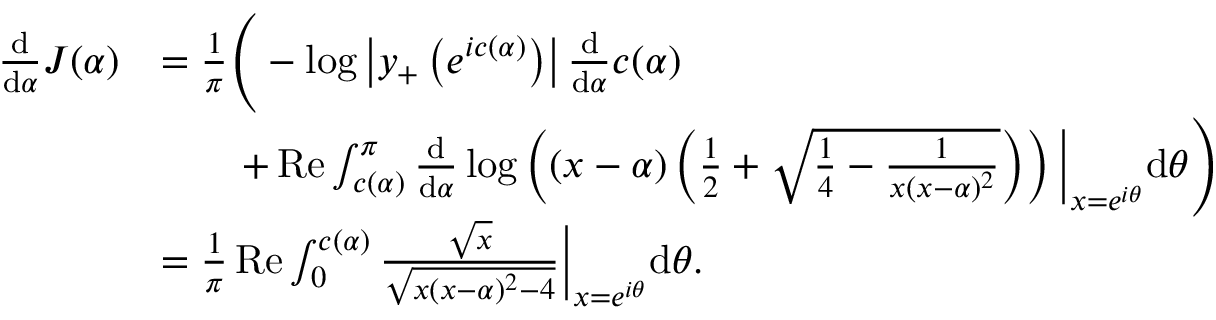Convert formula to latex. <formula><loc_0><loc_0><loc_500><loc_500>\begin{array} { r l } { \frac { \mathrm d } { \mathrm d \alpha } J ( \alpha ) } & { = \frac { 1 } { \pi } \left ( - \log \left | y _ { + } \left ( e ^ { i c ( \alpha ) } \right ) \right | \frac { \mathrm d } { \mathrm d \alpha } c ( \alpha ) } \\ & { \quad + R e \int _ { c ( \alpha ) } ^ { \pi } \frac { \mathrm d } { \mathrm d \alpha } \log \left ( ( x - \alpha ) \left ( \frac { 1 } { 2 } + \sqrt { \frac { 1 } { 4 } - \frac { 1 } { x ( x - \alpha ) ^ { 2 } } } \right ) \right ) \left | _ { x = e ^ { i \theta } } \mathrm d \theta \right ) } \\ & { = \frac { 1 } { \pi } R e \int _ { 0 } ^ { c ( \alpha ) } \frac { \sqrt { x } } { \sqrt { x ( x - \alpha ) ^ { 2 } - 4 } } \right | _ { x = e ^ { i \theta } } \mathrm d \theta . } \end{array}</formula> 